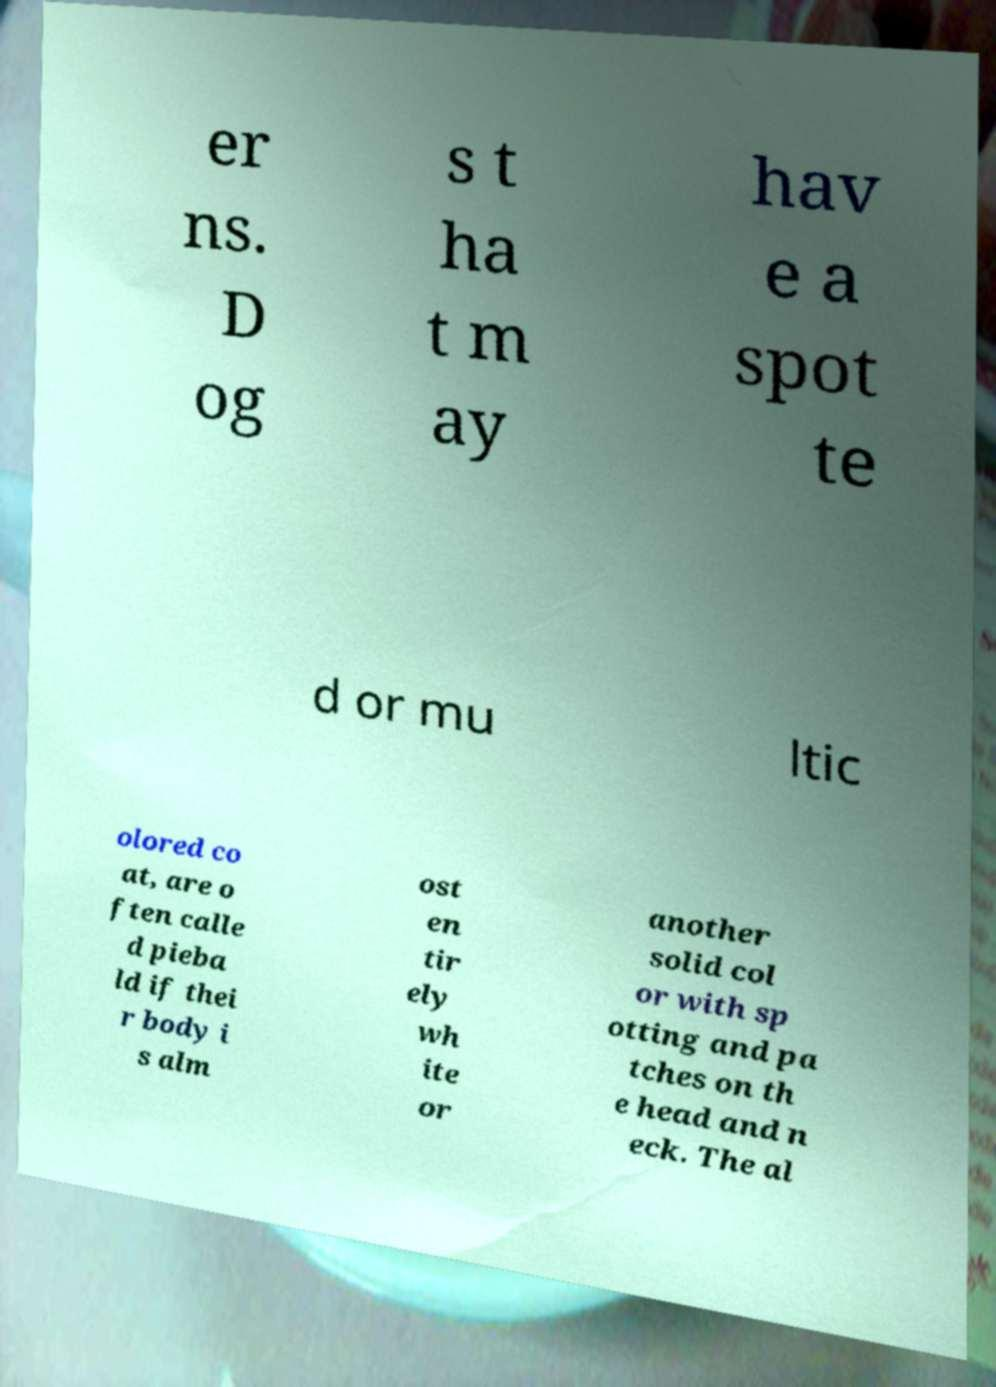Please read and relay the text visible in this image. What does it say? er ns. D og s t ha t m ay hav e a spot te d or mu ltic olored co at, are o ften calle d pieba ld if thei r body i s alm ost en tir ely wh ite or another solid col or with sp otting and pa tches on th e head and n eck. The al 